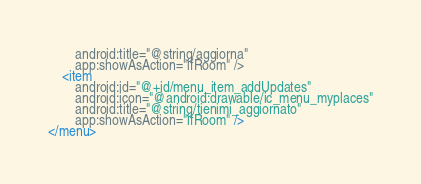<code> <loc_0><loc_0><loc_500><loc_500><_XML_>        android:title="@string/aggiorna"
        app:showAsAction="ifRoom" />
    <item
        android:id="@+id/menu_item_addUpdates"
        android:icon="@android:drawable/ic_menu_myplaces"
        android:title="@string/tienimi_aggiornato"
        app:showAsAction="ifRoom" />
</menu></code> 